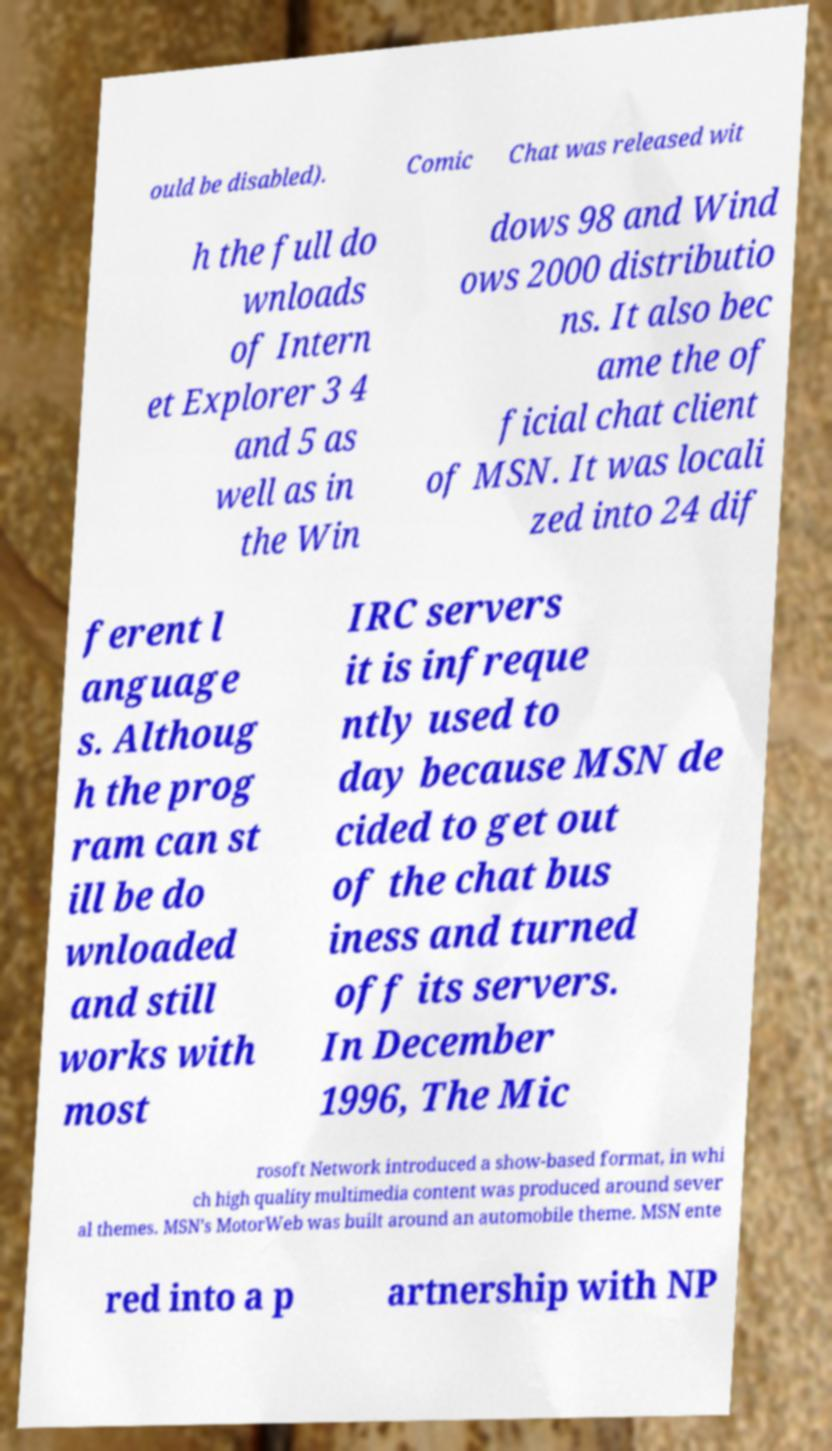I need the written content from this picture converted into text. Can you do that? ould be disabled). Comic Chat was released wit h the full do wnloads of Intern et Explorer 3 4 and 5 as well as in the Win dows 98 and Wind ows 2000 distributio ns. It also bec ame the of ficial chat client of MSN. It was locali zed into 24 dif ferent l anguage s. Althoug h the prog ram can st ill be do wnloaded and still works with most IRC servers it is infreque ntly used to day because MSN de cided to get out of the chat bus iness and turned off its servers. In December 1996, The Mic rosoft Network introduced a show-based format, in whi ch high quality multimedia content was produced around sever al themes. MSN's MotorWeb was built around an automobile theme. MSN ente red into a p artnership with NP 